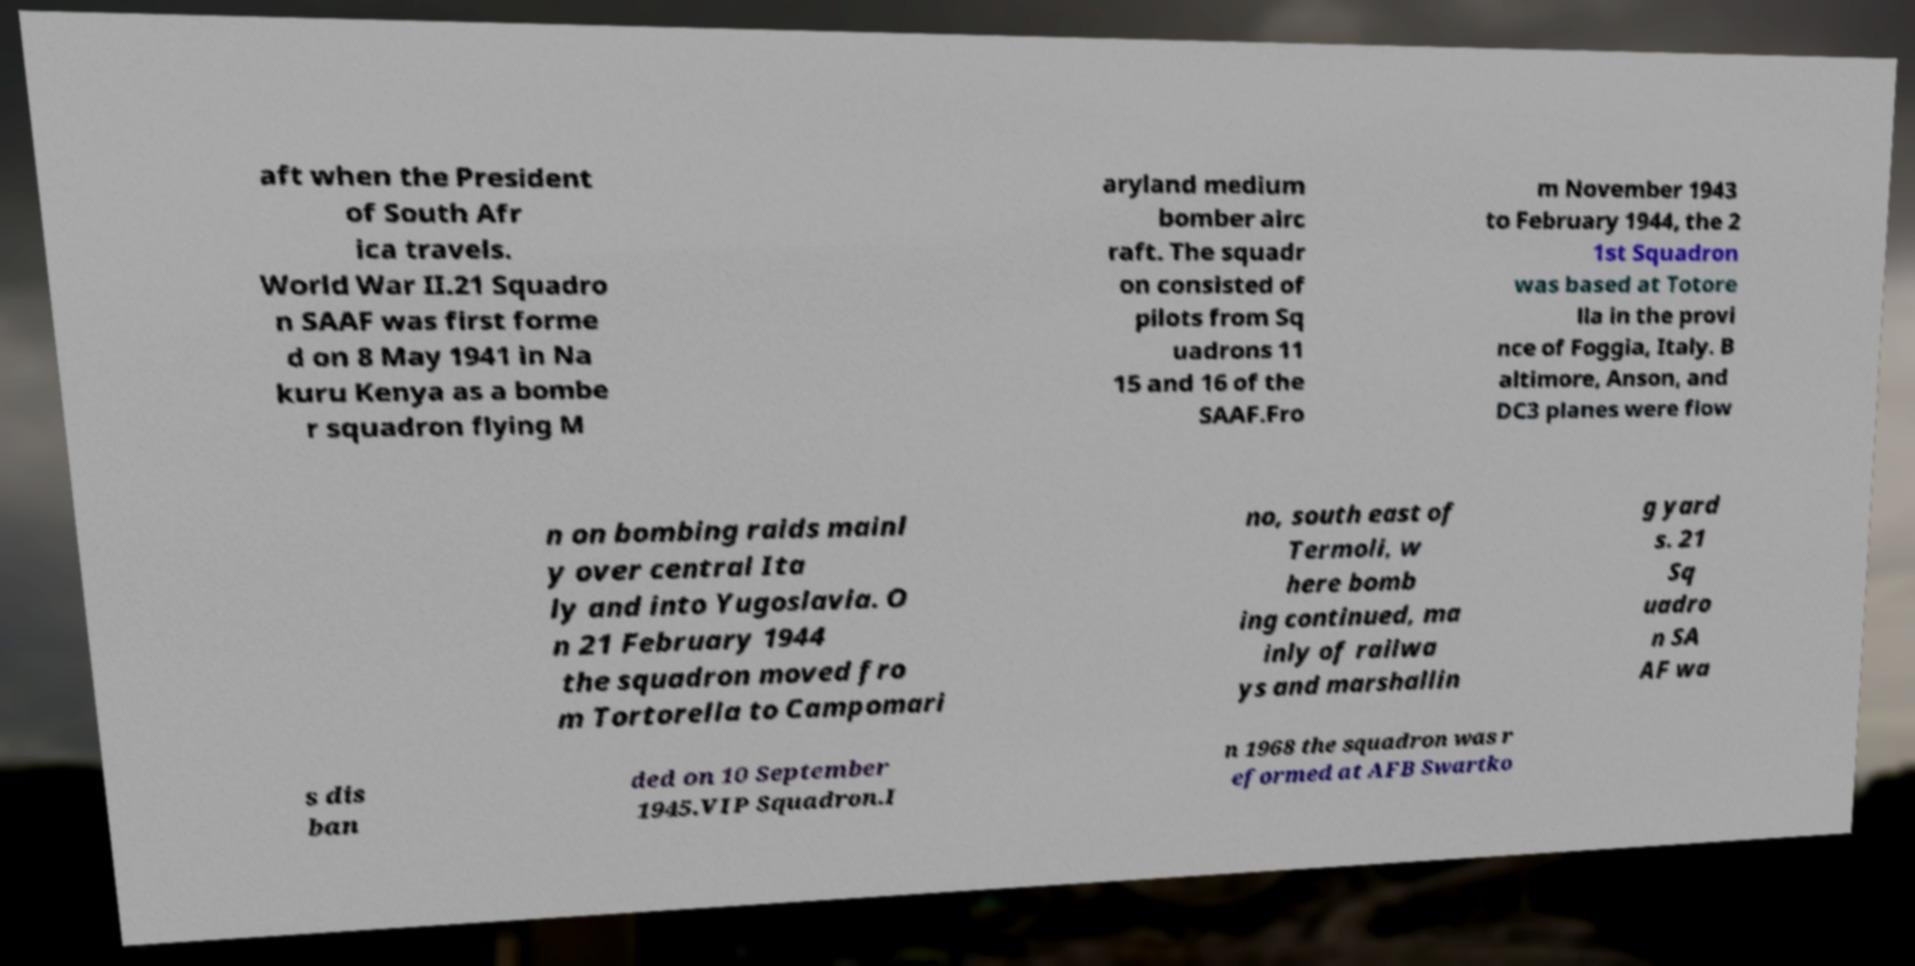Could you extract and type out the text from this image? aft when the President of South Afr ica travels. World War II.21 Squadro n SAAF was first forme d on 8 May 1941 in Na kuru Kenya as a bombe r squadron flying M aryland medium bomber airc raft. The squadr on consisted of pilots from Sq uadrons 11 15 and 16 of the SAAF.Fro m November 1943 to February 1944, the 2 1st Squadron was based at Totore lla in the provi nce of Foggia, Italy. B altimore, Anson, and DC3 planes were flow n on bombing raids mainl y over central Ita ly and into Yugoslavia. O n 21 February 1944 the squadron moved fro m Tortorella to Campomari no, south east of Termoli, w here bomb ing continued, ma inly of railwa ys and marshallin g yard s. 21 Sq uadro n SA AF wa s dis ban ded on 10 September 1945.VIP Squadron.I n 1968 the squadron was r eformed at AFB Swartko 